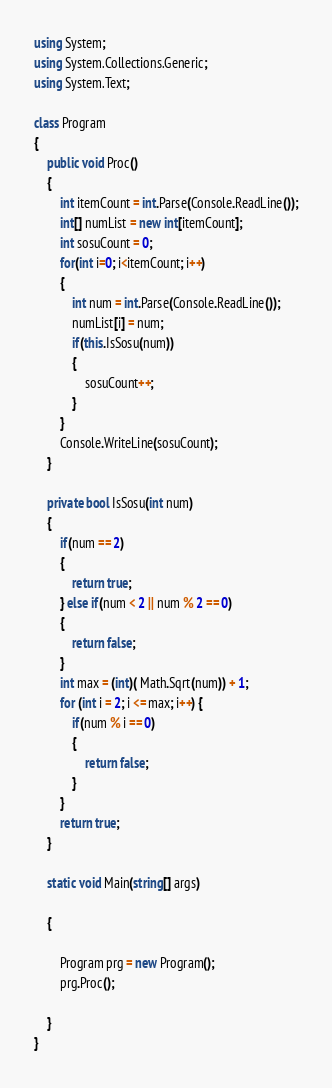<code> <loc_0><loc_0><loc_500><loc_500><_C#_>using System;
using System.Collections.Generic;
using System.Text;

class Program
{
    public void Proc()
    {
        int itemCount = int.Parse(Console.ReadLine());
        int[] numList = new int[itemCount];
        int sosuCount = 0;
        for(int i=0; i<itemCount; i++)
        {
            int num = int.Parse(Console.ReadLine());
            numList[i] = num;
            if(this.IsSosu(num))
            {
                sosuCount++;
            }
        }
        Console.WriteLine(sosuCount);
    }

    private bool IsSosu(int num)
    {
        if(num == 2)
        {
            return true;
        } else if(num < 2 || num % 2 == 0)
        {
            return false;
        }
        int max = (int)( Math.Sqrt(num)) + 1;
        for (int i = 2; i <= max; i++) {
            if(num % i == 0)
            {
                return false;
            }
        }
        return true;
    }

    static void Main(string[] args)

    {

        Program prg = new Program();
        prg.Proc();

    }
}</code> 